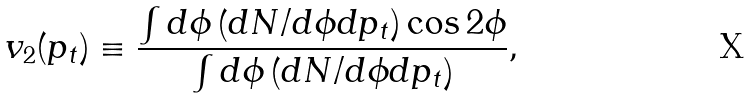Convert formula to latex. <formula><loc_0><loc_0><loc_500><loc_500>v _ { 2 } ( p _ { t } ) \equiv \frac { \int d \phi \left ( d N / d \phi d p _ { t } \right ) \cos 2 \phi } { \int d \phi \left ( d N / d \phi d p _ { t } \right ) } ,</formula> 